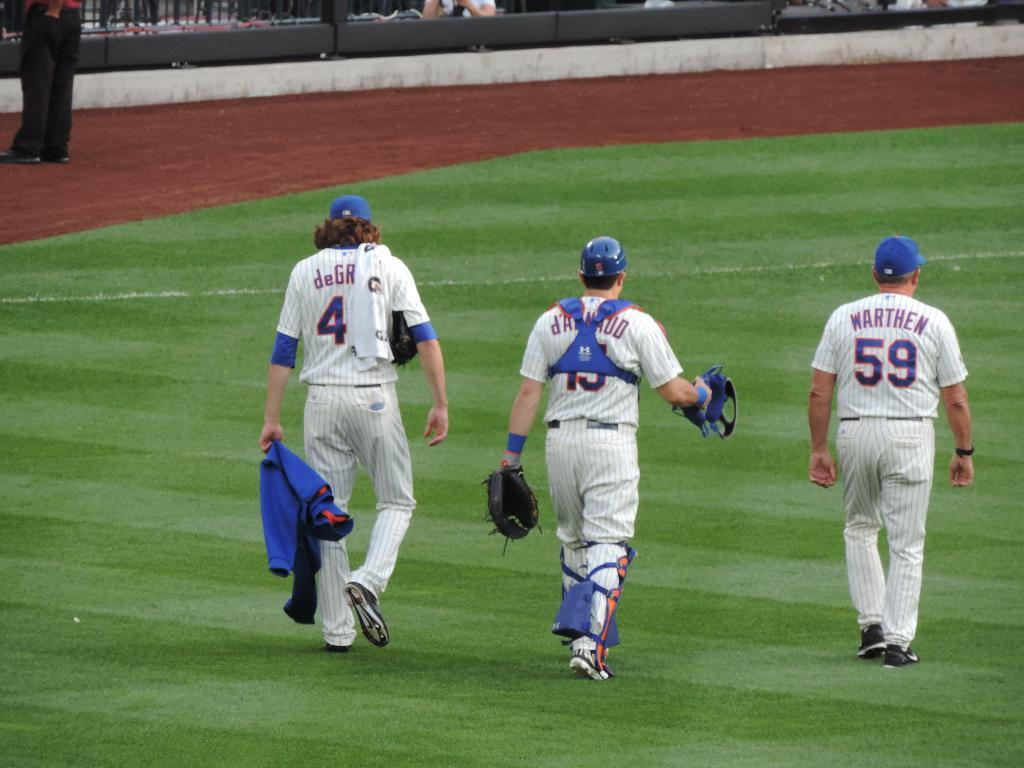<image>
Render a clear and concise summary of the photo. Coach Warthen walks on the field with his catcher and pitcher. 